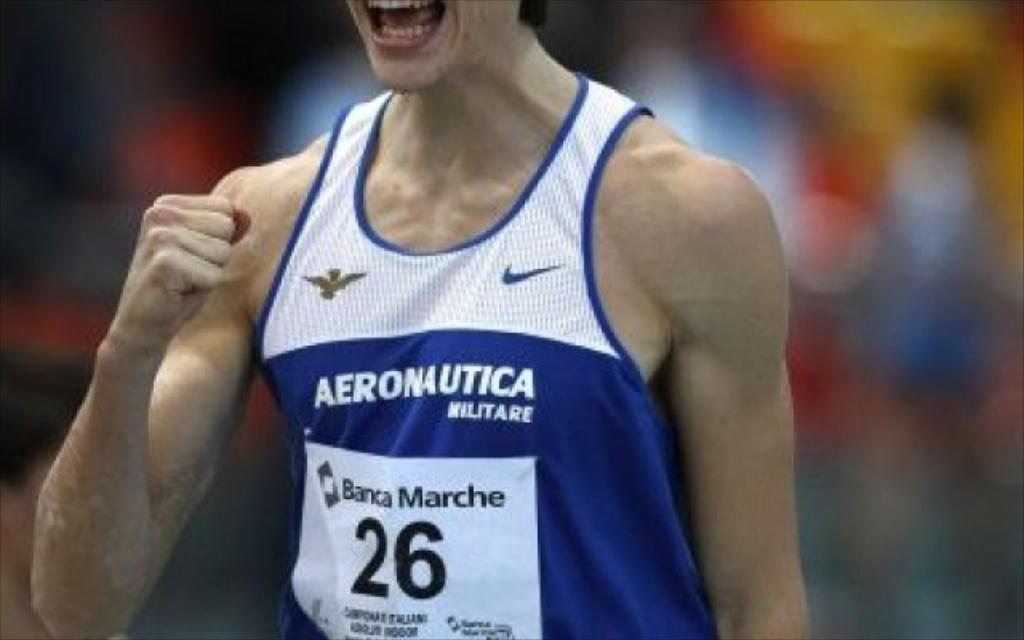Provide a one-sentence caption for the provided image. A male sports player wearing a blue and white tank top jersey that says Aeronautica. 